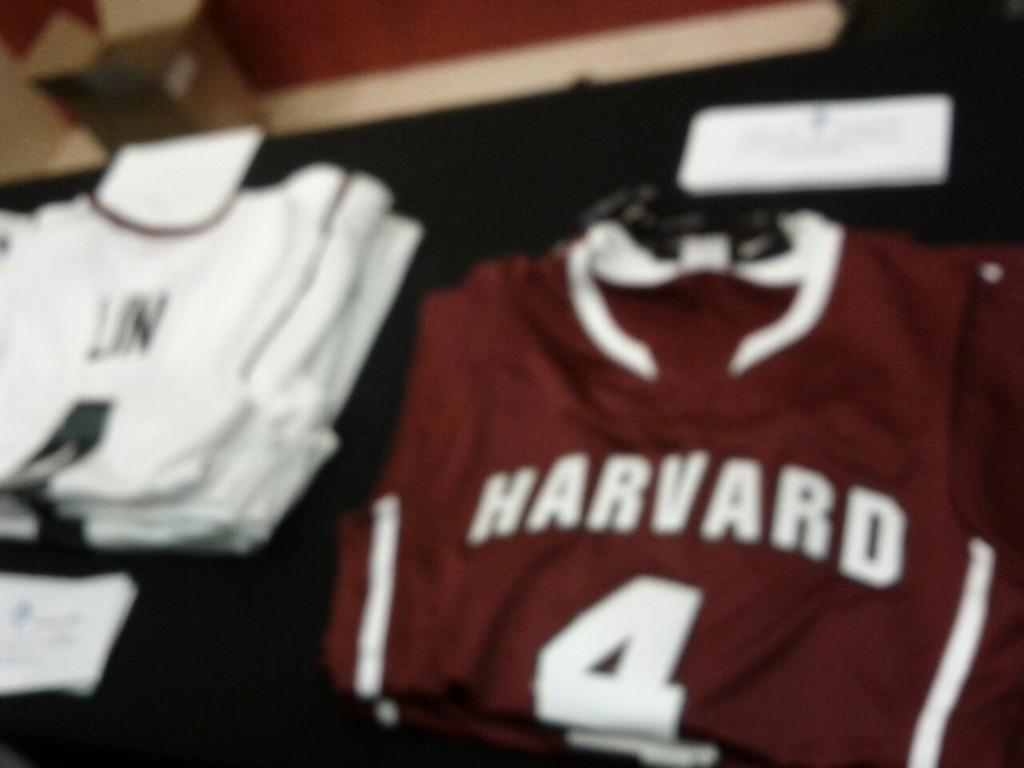What type of clothing items are visible in the image? There are T-shirts in the image. What is the color of the surface on which the T-shirts are placed? The T-shirts are on a black color surface. Can you see any worms crawling on the T-shirts in the image? No, there are no worms visible in the image. 